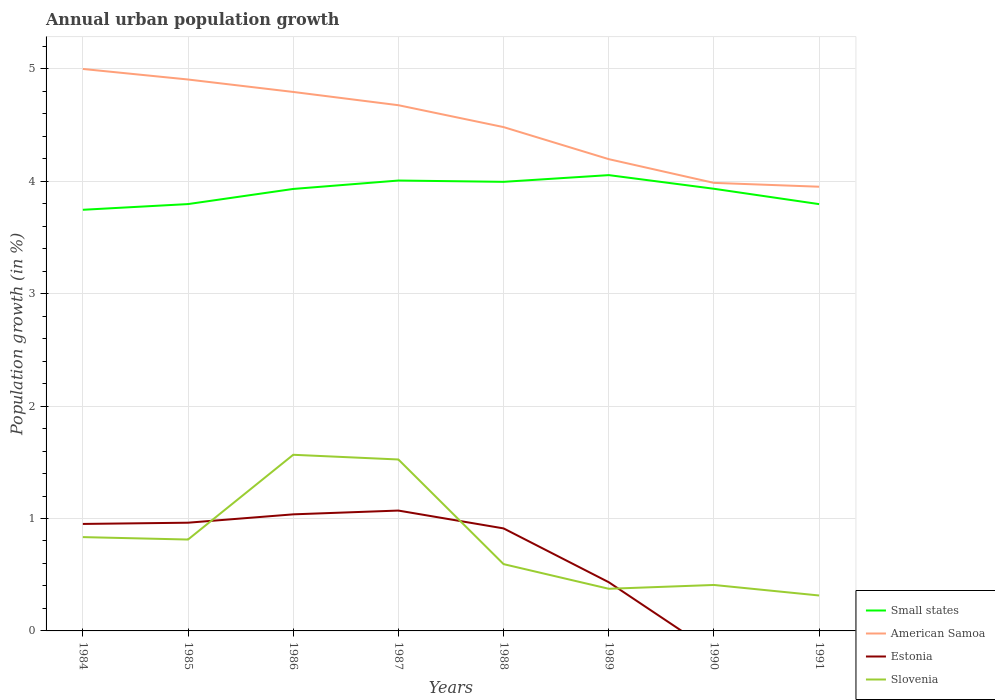How many different coloured lines are there?
Offer a very short reply. 4. Does the line corresponding to Small states intersect with the line corresponding to Slovenia?
Ensure brevity in your answer.  No. Is the number of lines equal to the number of legend labels?
Your answer should be compact. No. Across all years, what is the maximum percentage of urban population growth in Small states?
Your response must be concise. 3.75. What is the total percentage of urban population growth in American Samoa in the graph?
Give a very brief answer. 0.29. What is the difference between the highest and the second highest percentage of urban population growth in Estonia?
Offer a very short reply. 1.07. What is the difference between the highest and the lowest percentage of urban population growth in Small states?
Ensure brevity in your answer.  5. How many years are there in the graph?
Your response must be concise. 8. What is the difference between two consecutive major ticks on the Y-axis?
Your answer should be very brief. 1. How many legend labels are there?
Offer a terse response. 4. How are the legend labels stacked?
Make the answer very short. Vertical. What is the title of the graph?
Ensure brevity in your answer.  Annual urban population growth. Does "Tunisia" appear as one of the legend labels in the graph?
Keep it short and to the point. No. What is the label or title of the X-axis?
Your answer should be very brief. Years. What is the label or title of the Y-axis?
Your response must be concise. Population growth (in %). What is the Population growth (in %) in Small states in 1984?
Offer a very short reply. 3.75. What is the Population growth (in %) in American Samoa in 1984?
Your response must be concise. 5. What is the Population growth (in %) of Estonia in 1984?
Keep it short and to the point. 0.95. What is the Population growth (in %) of Slovenia in 1984?
Provide a short and direct response. 0.83. What is the Population growth (in %) of Small states in 1985?
Your answer should be very brief. 3.8. What is the Population growth (in %) of American Samoa in 1985?
Keep it short and to the point. 4.91. What is the Population growth (in %) of Estonia in 1985?
Your answer should be compact. 0.96. What is the Population growth (in %) in Slovenia in 1985?
Provide a short and direct response. 0.81. What is the Population growth (in %) of Small states in 1986?
Make the answer very short. 3.93. What is the Population growth (in %) of American Samoa in 1986?
Make the answer very short. 4.79. What is the Population growth (in %) of Estonia in 1986?
Offer a very short reply. 1.04. What is the Population growth (in %) of Slovenia in 1986?
Your answer should be very brief. 1.57. What is the Population growth (in %) in Small states in 1987?
Offer a terse response. 4.01. What is the Population growth (in %) in American Samoa in 1987?
Provide a short and direct response. 4.68. What is the Population growth (in %) of Estonia in 1987?
Your answer should be very brief. 1.07. What is the Population growth (in %) of Slovenia in 1987?
Give a very brief answer. 1.53. What is the Population growth (in %) of Small states in 1988?
Your response must be concise. 4. What is the Population growth (in %) of American Samoa in 1988?
Keep it short and to the point. 4.48. What is the Population growth (in %) in Estonia in 1988?
Your answer should be compact. 0.91. What is the Population growth (in %) in Slovenia in 1988?
Your answer should be compact. 0.59. What is the Population growth (in %) of Small states in 1989?
Your answer should be very brief. 4.05. What is the Population growth (in %) of American Samoa in 1989?
Ensure brevity in your answer.  4.2. What is the Population growth (in %) in Estonia in 1989?
Offer a terse response. 0.43. What is the Population growth (in %) of Slovenia in 1989?
Provide a short and direct response. 0.37. What is the Population growth (in %) of Small states in 1990?
Offer a terse response. 3.93. What is the Population growth (in %) in American Samoa in 1990?
Keep it short and to the point. 3.99. What is the Population growth (in %) of Estonia in 1990?
Offer a terse response. 0. What is the Population growth (in %) of Slovenia in 1990?
Give a very brief answer. 0.41. What is the Population growth (in %) in Small states in 1991?
Give a very brief answer. 3.8. What is the Population growth (in %) of American Samoa in 1991?
Offer a very short reply. 3.95. What is the Population growth (in %) in Slovenia in 1991?
Make the answer very short. 0.32. Across all years, what is the maximum Population growth (in %) of Small states?
Provide a succinct answer. 4.05. Across all years, what is the maximum Population growth (in %) of American Samoa?
Offer a terse response. 5. Across all years, what is the maximum Population growth (in %) of Estonia?
Provide a succinct answer. 1.07. Across all years, what is the maximum Population growth (in %) in Slovenia?
Ensure brevity in your answer.  1.57. Across all years, what is the minimum Population growth (in %) in Small states?
Provide a short and direct response. 3.75. Across all years, what is the minimum Population growth (in %) of American Samoa?
Offer a terse response. 3.95. Across all years, what is the minimum Population growth (in %) of Slovenia?
Make the answer very short. 0.32. What is the total Population growth (in %) of Small states in the graph?
Give a very brief answer. 31.26. What is the total Population growth (in %) in American Samoa in the graph?
Keep it short and to the point. 35.99. What is the total Population growth (in %) in Estonia in the graph?
Offer a terse response. 5.37. What is the total Population growth (in %) of Slovenia in the graph?
Provide a succinct answer. 6.43. What is the difference between the Population growth (in %) in Small states in 1984 and that in 1985?
Ensure brevity in your answer.  -0.05. What is the difference between the Population growth (in %) of American Samoa in 1984 and that in 1985?
Ensure brevity in your answer.  0.09. What is the difference between the Population growth (in %) of Estonia in 1984 and that in 1985?
Offer a very short reply. -0.01. What is the difference between the Population growth (in %) of Slovenia in 1984 and that in 1985?
Your response must be concise. 0.02. What is the difference between the Population growth (in %) of Small states in 1984 and that in 1986?
Make the answer very short. -0.19. What is the difference between the Population growth (in %) of American Samoa in 1984 and that in 1986?
Your answer should be very brief. 0.2. What is the difference between the Population growth (in %) in Estonia in 1984 and that in 1986?
Offer a terse response. -0.09. What is the difference between the Population growth (in %) of Slovenia in 1984 and that in 1986?
Give a very brief answer. -0.73. What is the difference between the Population growth (in %) of Small states in 1984 and that in 1987?
Your answer should be very brief. -0.26. What is the difference between the Population growth (in %) of American Samoa in 1984 and that in 1987?
Your answer should be very brief. 0.32. What is the difference between the Population growth (in %) in Estonia in 1984 and that in 1987?
Provide a short and direct response. -0.12. What is the difference between the Population growth (in %) in Slovenia in 1984 and that in 1987?
Give a very brief answer. -0.69. What is the difference between the Population growth (in %) in Small states in 1984 and that in 1988?
Offer a very short reply. -0.25. What is the difference between the Population growth (in %) in American Samoa in 1984 and that in 1988?
Give a very brief answer. 0.52. What is the difference between the Population growth (in %) in Estonia in 1984 and that in 1988?
Your answer should be compact. 0.04. What is the difference between the Population growth (in %) in Slovenia in 1984 and that in 1988?
Your response must be concise. 0.24. What is the difference between the Population growth (in %) of Small states in 1984 and that in 1989?
Keep it short and to the point. -0.31. What is the difference between the Population growth (in %) in American Samoa in 1984 and that in 1989?
Your answer should be compact. 0.8. What is the difference between the Population growth (in %) of Estonia in 1984 and that in 1989?
Your answer should be very brief. 0.52. What is the difference between the Population growth (in %) of Slovenia in 1984 and that in 1989?
Give a very brief answer. 0.46. What is the difference between the Population growth (in %) of Small states in 1984 and that in 1990?
Your response must be concise. -0.19. What is the difference between the Population growth (in %) in American Samoa in 1984 and that in 1990?
Keep it short and to the point. 1.01. What is the difference between the Population growth (in %) in Slovenia in 1984 and that in 1990?
Keep it short and to the point. 0.43. What is the difference between the Population growth (in %) of Small states in 1984 and that in 1991?
Keep it short and to the point. -0.05. What is the difference between the Population growth (in %) in American Samoa in 1984 and that in 1991?
Your response must be concise. 1.05. What is the difference between the Population growth (in %) in Slovenia in 1984 and that in 1991?
Offer a very short reply. 0.52. What is the difference between the Population growth (in %) of Small states in 1985 and that in 1986?
Make the answer very short. -0.13. What is the difference between the Population growth (in %) of American Samoa in 1985 and that in 1986?
Offer a terse response. 0.11. What is the difference between the Population growth (in %) in Estonia in 1985 and that in 1986?
Your answer should be compact. -0.07. What is the difference between the Population growth (in %) in Slovenia in 1985 and that in 1986?
Provide a succinct answer. -0.75. What is the difference between the Population growth (in %) in Small states in 1985 and that in 1987?
Keep it short and to the point. -0.21. What is the difference between the Population growth (in %) of American Samoa in 1985 and that in 1987?
Give a very brief answer. 0.23. What is the difference between the Population growth (in %) of Estonia in 1985 and that in 1987?
Give a very brief answer. -0.11. What is the difference between the Population growth (in %) in Slovenia in 1985 and that in 1987?
Provide a short and direct response. -0.71. What is the difference between the Population growth (in %) in Small states in 1985 and that in 1988?
Your answer should be compact. -0.2. What is the difference between the Population growth (in %) of American Samoa in 1985 and that in 1988?
Keep it short and to the point. 0.42. What is the difference between the Population growth (in %) of Estonia in 1985 and that in 1988?
Make the answer very short. 0.05. What is the difference between the Population growth (in %) in Slovenia in 1985 and that in 1988?
Your answer should be very brief. 0.22. What is the difference between the Population growth (in %) of Small states in 1985 and that in 1989?
Provide a succinct answer. -0.26. What is the difference between the Population growth (in %) in American Samoa in 1985 and that in 1989?
Offer a terse response. 0.71. What is the difference between the Population growth (in %) in Estonia in 1985 and that in 1989?
Make the answer very short. 0.53. What is the difference between the Population growth (in %) of Slovenia in 1985 and that in 1989?
Offer a very short reply. 0.44. What is the difference between the Population growth (in %) of Small states in 1985 and that in 1990?
Offer a very short reply. -0.14. What is the difference between the Population growth (in %) of American Samoa in 1985 and that in 1990?
Provide a succinct answer. 0.92. What is the difference between the Population growth (in %) of Slovenia in 1985 and that in 1990?
Your response must be concise. 0.4. What is the difference between the Population growth (in %) of American Samoa in 1985 and that in 1991?
Offer a very short reply. 0.95. What is the difference between the Population growth (in %) in Slovenia in 1985 and that in 1991?
Your answer should be compact. 0.5. What is the difference between the Population growth (in %) in Small states in 1986 and that in 1987?
Your answer should be compact. -0.07. What is the difference between the Population growth (in %) of American Samoa in 1986 and that in 1987?
Provide a short and direct response. 0.12. What is the difference between the Population growth (in %) of Estonia in 1986 and that in 1987?
Make the answer very short. -0.03. What is the difference between the Population growth (in %) of Slovenia in 1986 and that in 1987?
Provide a short and direct response. 0.04. What is the difference between the Population growth (in %) of Small states in 1986 and that in 1988?
Your response must be concise. -0.06. What is the difference between the Population growth (in %) in American Samoa in 1986 and that in 1988?
Your answer should be compact. 0.31. What is the difference between the Population growth (in %) in Estonia in 1986 and that in 1988?
Your response must be concise. 0.13. What is the difference between the Population growth (in %) of Slovenia in 1986 and that in 1988?
Provide a short and direct response. 0.97. What is the difference between the Population growth (in %) of Small states in 1986 and that in 1989?
Your answer should be very brief. -0.12. What is the difference between the Population growth (in %) in American Samoa in 1986 and that in 1989?
Give a very brief answer. 0.6. What is the difference between the Population growth (in %) of Estonia in 1986 and that in 1989?
Offer a terse response. 0.6. What is the difference between the Population growth (in %) of Slovenia in 1986 and that in 1989?
Provide a succinct answer. 1.19. What is the difference between the Population growth (in %) of Small states in 1986 and that in 1990?
Ensure brevity in your answer.  -0. What is the difference between the Population growth (in %) in American Samoa in 1986 and that in 1990?
Offer a terse response. 0.81. What is the difference between the Population growth (in %) in Slovenia in 1986 and that in 1990?
Keep it short and to the point. 1.16. What is the difference between the Population growth (in %) of Small states in 1986 and that in 1991?
Give a very brief answer. 0.14. What is the difference between the Population growth (in %) in American Samoa in 1986 and that in 1991?
Provide a short and direct response. 0.84. What is the difference between the Population growth (in %) of Slovenia in 1986 and that in 1991?
Give a very brief answer. 1.25. What is the difference between the Population growth (in %) in Small states in 1987 and that in 1988?
Offer a very short reply. 0.01. What is the difference between the Population growth (in %) in American Samoa in 1987 and that in 1988?
Provide a short and direct response. 0.19. What is the difference between the Population growth (in %) in Estonia in 1987 and that in 1988?
Give a very brief answer. 0.16. What is the difference between the Population growth (in %) of Small states in 1987 and that in 1989?
Provide a succinct answer. -0.05. What is the difference between the Population growth (in %) in American Samoa in 1987 and that in 1989?
Give a very brief answer. 0.48. What is the difference between the Population growth (in %) of Estonia in 1987 and that in 1989?
Offer a very short reply. 0.64. What is the difference between the Population growth (in %) in Slovenia in 1987 and that in 1989?
Keep it short and to the point. 1.15. What is the difference between the Population growth (in %) of Small states in 1987 and that in 1990?
Offer a terse response. 0.07. What is the difference between the Population growth (in %) in American Samoa in 1987 and that in 1990?
Offer a terse response. 0.69. What is the difference between the Population growth (in %) of Slovenia in 1987 and that in 1990?
Offer a very short reply. 1.12. What is the difference between the Population growth (in %) of Small states in 1987 and that in 1991?
Give a very brief answer. 0.21. What is the difference between the Population growth (in %) in American Samoa in 1987 and that in 1991?
Give a very brief answer. 0.73. What is the difference between the Population growth (in %) in Slovenia in 1987 and that in 1991?
Offer a terse response. 1.21. What is the difference between the Population growth (in %) of Small states in 1988 and that in 1989?
Provide a succinct answer. -0.06. What is the difference between the Population growth (in %) in American Samoa in 1988 and that in 1989?
Your answer should be very brief. 0.29. What is the difference between the Population growth (in %) of Estonia in 1988 and that in 1989?
Ensure brevity in your answer.  0.48. What is the difference between the Population growth (in %) in Slovenia in 1988 and that in 1989?
Your response must be concise. 0.22. What is the difference between the Population growth (in %) in Small states in 1988 and that in 1990?
Offer a very short reply. 0.06. What is the difference between the Population growth (in %) in American Samoa in 1988 and that in 1990?
Keep it short and to the point. 0.5. What is the difference between the Population growth (in %) in Slovenia in 1988 and that in 1990?
Your answer should be compact. 0.19. What is the difference between the Population growth (in %) in Small states in 1988 and that in 1991?
Your answer should be compact. 0.2. What is the difference between the Population growth (in %) of American Samoa in 1988 and that in 1991?
Provide a short and direct response. 0.53. What is the difference between the Population growth (in %) of Slovenia in 1988 and that in 1991?
Keep it short and to the point. 0.28. What is the difference between the Population growth (in %) of Small states in 1989 and that in 1990?
Your answer should be very brief. 0.12. What is the difference between the Population growth (in %) of American Samoa in 1989 and that in 1990?
Your response must be concise. 0.21. What is the difference between the Population growth (in %) in Slovenia in 1989 and that in 1990?
Give a very brief answer. -0.03. What is the difference between the Population growth (in %) of Small states in 1989 and that in 1991?
Provide a short and direct response. 0.26. What is the difference between the Population growth (in %) in American Samoa in 1989 and that in 1991?
Provide a short and direct response. 0.25. What is the difference between the Population growth (in %) of Slovenia in 1989 and that in 1991?
Make the answer very short. 0.06. What is the difference between the Population growth (in %) of Small states in 1990 and that in 1991?
Provide a succinct answer. 0.14. What is the difference between the Population growth (in %) of American Samoa in 1990 and that in 1991?
Keep it short and to the point. 0.03. What is the difference between the Population growth (in %) of Slovenia in 1990 and that in 1991?
Give a very brief answer. 0.09. What is the difference between the Population growth (in %) in Small states in 1984 and the Population growth (in %) in American Samoa in 1985?
Offer a very short reply. -1.16. What is the difference between the Population growth (in %) in Small states in 1984 and the Population growth (in %) in Estonia in 1985?
Ensure brevity in your answer.  2.78. What is the difference between the Population growth (in %) in Small states in 1984 and the Population growth (in %) in Slovenia in 1985?
Give a very brief answer. 2.93. What is the difference between the Population growth (in %) of American Samoa in 1984 and the Population growth (in %) of Estonia in 1985?
Offer a terse response. 4.04. What is the difference between the Population growth (in %) of American Samoa in 1984 and the Population growth (in %) of Slovenia in 1985?
Offer a terse response. 4.19. What is the difference between the Population growth (in %) in Estonia in 1984 and the Population growth (in %) in Slovenia in 1985?
Keep it short and to the point. 0.14. What is the difference between the Population growth (in %) in Small states in 1984 and the Population growth (in %) in American Samoa in 1986?
Offer a terse response. -1.05. What is the difference between the Population growth (in %) in Small states in 1984 and the Population growth (in %) in Estonia in 1986?
Your answer should be very brief. 2.71. What is the difference between the Population growth (in %) of Small states in 1984 and the Population growth (in %) of Slovenia in 1986?
Offer a terse response. 2.18. What is the difference between the Population growth (in %) of American Samoa in 1984 and the Population growth (in %) of Estonia in 1986?
Make the answer very short. 3.96. What is the difference between the Population growth (in %) of American Samoa in 1984 and the Population growth (in %) of Slovenia in 1986?
Provide a short and direct response. 3.43. What is the difference between the Population growth (in %) in Estonia in 1984 and the Population growth (in %) in Slovenia in 1986?
Offer a terse response. -0.62. What is the difference between the Population growth (in %) in Small states in 1984 and the Population growth (in %) in American Samoa in 1987?
Offer a very short reply. -0.93. What is the difference between the Population growth (in %) in Small states in 1984 and the Population growth (in %) in Estonia in 1987?
Keep it short and to the point. 2.68. What is the difference between the Population growth (in %) in Small states in 1984 and the Population growth (in %) in Slovenia in 1987?
Give a very brief answer. 2.22. What is the difference between the Population growth (in %) in American Samoa in 1984 and the Population growth (in %) in Estonia in 1987?
Provide a short and direct response. 3.93. What is the difference between the Population growth (in %) of American Samoa in 1984 and the Population growth (in %) of Slovenia in 1987?
Give a very brief answer. 3.47. What is the difference between the Population growth (in %) in Estonia in 1984 and the Population growth (in %) in Slovenia in 1987?
Provide a short and direct response. -0.57. What is the difference between the Population growth (in %) of Small states in 1984 and the Population growth (in %) of American Samoa in 1988?
Provide a succinct answer. -0.74. What is the difference between the Population growth (in %) of Small states in 1984 and the Population growth (in %) of Estonia in 1988?
Give a very brief answer. 2.83. What is the difference between the Population growth (in %) of Small states in 1984 and the Population growth (in %) of Slovenia in 1988?
Offer a very short reply. 3.15. What is the difference between the Population growth (in %) of American Samoa in 1984 and the Population growth (in %) of Estonia in 1988?
Provide a succinct answer. 4.09. What is the difference between the Population growth (in %) of American Samoa in 1984 and the Population growth (in %) of Slovenia in 1988?
Offer a very short reply. 4.41. What is the difference between the Population growth (in %) of Estonia in 1984 and the Population growth (in %) of Slovenia in 1988?
Offer a terse response. 0.36. What is the difference between the Population growth (in %) of Small states in 1984 and the Population growth (in %) of American Samoa in 1989?
Provide a succinct answer. -0.45. What is the difference between the Population growth (in %) of Small states in 1984 and the Population growth (in %) of Estonia in 1989?
Give a very brief answer. 3.31. What is the difference between the Population growth (in %) of Small states in 1984 and the Population growth (in %) of Slovenia in 1989?
Your answer should be compact. 3.37. What is the difference between the Population growth (in %) in American Samoa in 1984 and the Population growth (in %) in Estonia in 1989?
Your response must be concise. 4.57. What is the difference between the Population growth (in %) of American Samoa in 1984 and the Population growth (in %) of Slovenia in 1989?
Offer a terse response. 4.62. What is the difference between the Population growth (in %) of Estonia in 1984 and the Population growth (in %) of Slovenia in 1989?
Provide a short and direct response. 0.58. What is the difference between the Population growth (in %) of Small states in 1984 and the Population growth (in %) of American Samoa in 1990?
Keep it short and to the point. -0.24. What is the difference between the Population growth (in %) of Small states in 1984 and the Population growth (in %) of Slovenia in 1990?
Offer a very short reply. 3.34. What is the difference between the Population growth (in %) of American Samoa in 1984 and the Population growth (in %) of Slovenia in 1990?
Offer a very short reply. 4.59. What is the difference between the Population growth (in %) in Estonia in 1984 and the Population growth (in %) in Slovenia in 1990?
Your answer should be compact. 0.54. What is the difference between the Population growth (in %) in Small states in 1984 and the Population growth (in %) in American Samoa in 1991?
Provide a succinct answer. -0.21. What is the difference between the Population growth (in %) in Small states in 1984 and the Population growth (in %) in Slovenia in 1991?
Your answer should be compact. 3.43. What is the difference between the Population growth (in %) of American Samoa in 1984 and the Population growth (in %) of Slovenia in 1991?
Your answer should be compact. 4.68. What is the difference between the Population growth (in %) of Estonia in 1984 and the Population growth (in %) of Slovenia in 1991?
Keep it short and to the point. 0.64. What is the difference between the Population growth (in %) in Small states in 1985 and the Population growth (in %) in American Samoa in 1986?
Your response must be concise. -1. What is the difference between the Population growth (in %) of Small states in 1985 and the Population growth (in %) of Estonia in 1986?
Make the answer very short. 2.76. What is the difference between the Population growth (in %) of Small states in 1985 and the Population growth (in %) of Slovenia in 1986?
Offer a very short reply. 2.23. What is the difference between the Population growth (in %) in American Samoa in 1985 and the Population growth (in %) in Estonia in 1986?
Provide a short and direct response. 3.87. What is the difference between the Population growth (in %) of American Samoa in 1985 and the Population growth (in %) of Slovenia in 1986?
Offer a terse response. 3.34. What is the difference between the Population growth (in %) in Estonia in 1985 and the Population growth (in %) in Slovenia in 1986?
Keep it short and to the point. -0.6. What is the difference between the Population growth (in %) of Small states in 1985 and the Population growth (in %) of American Samoa in 1987?
Provide a short and direct response. -0.88. What is the difference between the Population growth (in %) in Small states in 1985 and the Population growth (in %) in Estonia in 1987?
Offer a terse response. 2.73. What is the difference between the Population growth (in %) of Small states in 1985 and the Population growth (in %) of Slovenia in 1987?
Provide a short and direct response. 2.27. What is the difference between the Population growth (in %) in American Samoa in 1985 and the Population growth (in %) in Estonia in 1987?
Your answer should be very brief. 3.83. What is the difference between the Population growth (in %) in American Samoa in 1985 and the Population growth (in %) in Slovenia in 1987?
Offer a terse response. 3.38. What is the difference between the Population growth (in %) of Estonia in 1985 and the Population growth (in %) of Slovenia in 1987?
Provide a short and direct response. -0.56. What is the difference between the Population growth (in %) of Small states in 1985 and the Population growth (in %) of American Samoa in 1988?
Make the answer very short. -0.68. What is the difference between the Population growth (in %) in Small states in 1985 and the Population growth (in %) in Estonia in 1988?
Keep it short and to the point. 2.89. What is the difference between the Population growth (in %) in Small states in 1985 and the Population growth (in %) in Slovenia in 1988?
Keep it short and to the point. 3.2. What is the difference between the Population growth (in %) of American Samoa in 1985 and the Population growth (in %) of Estonia in 1988?
Keep it short and to the point. 3.99. What is the difference between the Population growth (in %) in American Samoa in 1985 and the Population growth (in %) in Slovenia in 1988?
Ensure brevity in your answer.  4.31. What is the difference between the Population growth (in %) of Estonia in 1985 and the Population growth (in %) of Slovenia in 1988?
Your response must be concise. 0.37. What is the difference between the Population growth (in %) of Small states in 1985 and the Population growth (in %) of American Samoa in 1989?
Offer a very short reply. -0.4. What is the difference between the Population growth (in %) in Small states in 1985 and the Population growth (in %) in Estonia in 1989?
Provide a short and direct response. 3.36. What is the difference between the Population growth (in %) of Small states in 1985 and the Population growth (in %) of Slovenia in 1989?
Your answer should be compact. 3.42. What is the difference between the Population growth (in %) of American Samoa in 1985 and the Population growth (in %) of Estonia in 1989?
Give a very brief answer. 4.47. What is the difference between the Population growth (in %) of American Samoa in 1985 and the Population growth (in %) of Slovenia in 1989?
Provide a succinct answer. 4.53. What is the difference between the Population growth (in %) in Estonia in 1985 and the Population growth (in %) in Slovenia in 1989?
Make the answer very short. 0.59. What is the difference between the Population growth (in %) in Small states in 1985 and the Population growth (in %) in American Samoa in 1990?
Give a very brief answer. -0.19. What is the difference between the Population growth (in %) of Small states in 1985 and the Population growth (in %) of Slovenia in 1990?
Offer a very short reply. 3.39. What is the difference between the Population growth (in %) of American Samoa in 1985 and the Population growth (in %) of Slovenia in 1990?
Offer a very short reply. 4.5. What is the difference between the Population growth (in %) in Estonia in 1985 and the Population growth (in %) in Slovenia in 1990?
Provide a short and direct response. 0.55. What is the difference between the Population growth (in %) in Small states in 1985 and the Population growth (in %) in American Samoa in 1991?
Provide a succinct answer. -0.15. What is the difference between the Population growth (in %) in Small states in 1985 and the Population growth (in %) in Slovenia in 1991?
Keep it short and to the point. 3.48. What is the difference between the Population growth (in %) of American Samoa in 1985 and the Population growth (in %) of Slovenia in 1991?
Make the answer very short. 4.59. What is the difference between the Population growth (in %) in Estonia in 1985 and the Population growth (in %) in Slovenia in 1991?
Keep it short and to the point. 0.65. What is the difference between the Population growth (in %) in Small states in 1986 and the Population growth (in %) in American Samoa in 1987?
Provide a succinct answer. -0.74. What is the difference between the Population growth (in %) in Small states in 1986 and the Population growth (in %) in Estonia in 1987?
Give a very brief answer. 2.86. What is the difference between the Population growth (in %) in Small states in 1986 and the Population growth (in %) in Slovenia in 1987?
Provide a succinct answer. 2.41. What is the difference between the Population growth (in %) of American Samoa in 1986 and the Population growth (in %) of Estonia in 1987?
Make the answer very short. 3.72. What is the difference between the Population growth (in %) in American Samoa in 1986 and the Population growth (in %) in Slovenia in 1987?
Provide a short and direct response. 3.27. What is the difference between the Population growth (in %) of Estonia in 1986 and the Population growth (in %) of Slovenia in 1987?
Provide a succinct answer. -0.49. What is the difference between the Population growth (in %) of Small states in 1986 and the Population growth (in %) of American Samoa in 1988?
Your answer should be compact. -0.55. What is the difference between the Population growth (in %) in Small states in 1986 and the Population growth (in %) in Estonia in 1988?
Provide a short and direct response. 3.02. What is the difference between the Population growth (in %) of Small states in 1986 and the Population growth (in %) of Slovenia in 1988?
Offer a terse response. 3.34. What is the difference between the Population growth (in %) in American Samoa in 1986 and the Population growth (in %) in Estonia in 1988?
Provide a succinct answer. 3.88. What is the difference between the Population growth (in %) in American Samoa in 1986 and the Population growth (in %) in Slovenia in 1988?
Your response must be concise. 4.2. What is the difference between the Population growth (in %) of Estonia in 1986 and the Population growth (in %) of Slovenia in 1988?
Your answer should be very brief. 0.44. What is the difference between the Population growth (in %) in Small states in 1986 and the Population growth (in %) in American Samoa in 1989?
Give a very brief answer. -0.27. What is the difference between the Population growth (in %) in Small states in 1986 and the Population growth (in %) in Estonia in 1989?
Offer a very short reply. 3.5. What is the difference between the Population growth (in %) of Small states in 1986 and the Population growth (in %) of Slovenia in 1989?
Provide a short and direct response. 3.56. What is the difference between the Population growth (in %) in American Samoa in 1986 and the Population growth (in %) in Estonia in 1989?
Your response must be concise. 4.36. What is the difference between the Population growth (in %) in American Samoa in 1986 and the Population growth (in %) in Slovenia in 1989?
Make the answer very short. 4.42. What is the difference between the Population growth (in %) of Estonia in 1986 and the Population growth (in %) of Slovenia in 1989?
Keep it short and to the point. 0.66. What is the difference between the Population growth (in %) in Small states in 1986 and the Population growth (in %) in American Samoa in 1990?
Your answer should be compact. -0.05. What is the difference between the Population growth (in %) of Small states in 1986 and the Population growth (in %) of Slovenia in 1990?
Offer a terse response. 3.52. What is the difference between the Population growth (in %) in American Samoa in 1986 and the Population growth (in %) in Slovenia in 1990?
Ensure brevity in your answer.  4.39. What is the difference between the Population growth (in %) in Estonia in 1986 and the Population growth (in %) in Slovenia in 1990?
Ensure brevity in your answer.  0.63. What is the difference between the Population growth (in %) in Small states in 1986 and the Population growth (in %) in American Samoa in 1991?
Offer a terse response. -0.02. What is the difference between the Population growth (in %) in Small states in 1986 and the Population growth (in %) in Slovenia in 1991?
Your answer should be very brief. 3.62. What is the difference between the Population growth (in %) of American Samoa in 1986 and the Population growth (in %) of Slovenia in 1991?
Give a very brief answer. 4.48. What is the difference between the Population growth (in %) in Estonia in 1986 and the Population growth (in %) in Slovenia in 1991?
Make the answer very short. 0.72. What is the difference between the Population growth (in %) of Small states in 1987 and the Population growth (in %) of American Samoa in 1988?
Your answer should be compact. -0.48. What is the difference between the Population growth (in %) in Small states in 1987 and the Population growth (in %) in Estonia in 1988?
Provide a succinct answer. 3.09. What is the difference between the Population growth (in %) in Small states in 1987 and the Population growth (in %) in Slovenia in 1988?
Keep it short and to the point. 3.41. What is the difference between the Population growth (in %) of American Samoa in 1987 and the Population growth (in %) of Estonia in 1988?
Your response must be concise. 3.76. What is the difference between the Population growth (in %) of American Samoa in 1987 and the Population growth (in %) of Slovenia in 1988?
Give a very brief answer. 4.08. What is the difference between the Population growth (in %) in Estonia in 1987 and the Population growth (in %) in Slovenia in 1988?
Your answer should be very brief. 0.48. What is the difference between the Population growth (in %) of Small states in 1987 and the Population growth (in %) of American Samoa in 1989?
Give a very brief answer. -0.19. What is the difference between the Population growth (in %) of Small states in 1987 and the Population growth (in %) of Estonia in 1989?
Give a very brief answer. 3.57. What is the difference between the Population growth (in %) in Small states in 1987 and the Population growth (in %) in Slovenia in 1989?
Your answer should be very brief. 3.63. What is the difference between the Population growth (in %) in American Samoa in 1987 and the Population growth (in %) in Estonia in 1989?
Give a very brief answer. 4.24. What is the difference between the Population growth (in %) of American Samoa in 1987 and the Population growth (in %) of Slovenia in 1989?
Give a very brief answer. 4.3. What is the difference between the Population growth (in %) of Estonia in 1987 and the Population growth (in %) of Slovenia in 1989?
Your answer should be compact. 0.7. What is the difference between the Population growth (in %) of Small states in 1987 and the Population growth (in %) of American Samoa in 1990?
Your response must be concise. 0.02. What is the difference between the Population growth (in %) of Small states in 1987 and the Population growth (in %) of Slovenia in 1990?
Provide a short and direct response. 3.6. What is the difference between the Population growth (in %) of American Samoa in 1987 and the Population growth (in %) of Slovenia in 1990?
Provide a succinct answer. 4.27. What is the difference between the Population growth (in %) of Estonia in 1987 and the Population growth (in %) of Slovenia in 1990?
Your response must be concise. 0.66. What is the difference between the Population growth (in %) in Small states in 1987 and the Population growth (in %) in American Samoa in 1991?
Give a very brief answer. 0.06. What is the difference between the Population growth (in %) in Small states in 1987 and the Population growth (in %) in Slovenia in 1991?
Keep it short and to the point. 3.69. What is the difference between the Population growth (in %) of American Samoa in 1987 and the Population growth (in %) of Slovenia in 1991?
Keep it short and to the point. 4.36. What is the difference between the Population growth (in %) of Estonia in 1987 and the Population growth (in %) of Slovenia in 1991?
Your answer should be very brief. 0.76. What is the difference between the Population growth (in %) in Small states in 1988 and the Population growth (in %) in American Samoa in 1989?
Your response must be concise. -0.2. What is the difference between the Population growth (in %) in Small states in 1988 and the Population growth (in %) in Estonia in 1989?
Your answer should be very brief. 3.56. What is the difference between the Population growth (in %) in Small states in 1988 and the Population growth (in %) in Slovenia in 1989?
Your answer should be compact. 3.62. What is the difference between the Population growth (in %) in American Samoa in 1988 and the Population growth (in %) in Estonia in 1989?
Provide a short and direct response. 4.05. What is the difference between the Population growth (in %) in American Samoa in 1988 and the Population growth (in %) in Slovenia in 1989?
Offer a terse response. 4.11. What is the difference between the Population growth (in %) of Estonia in 1988 and the Population growth (in %) of Slovenia in 1989?
Provide a short and direct response. 0.54. What is the difference between the Population growth (in %) of Small states in 1988 and the Population growth (in %) of American Samoa in 1990?
Offer a very short reply. 0.01. What is the difference between the Population growth (in %) in Small states in 1988 and the Population growth (in %) in Slovenia in 1990?
Provide a succinct answer. 3.59. What is the difference between the Population growth (in %) of American Samoa in 1988 and the Population growth (in %) of Slovenia in 1990?
Your answer should be very brief. 4.07. What is the difference between the Population growth (in %) of Estonia in 1988 and the Population growth (in %) of Slovenia in 1990?
Provide a succinct answer. 0.5. What is the difference between the Population growth (in %) in Small states in 1988 and the Population growth (in %) in American Samoa in 1991?
Ensure brevity in your answer.  0.04. What is the difference between the Population growth (in %) of Small states in 1988 and the Population growth (in %) of Slovenia in 1991?
Your answer should be compact. 3.68. What is the difference between the Population growth (in %) of American Samoa in 1988 and the Population growth (in %) of Slovenia in 1991?
Your response must be concise. 4.17. What is the difference between the Population growth (in %) in Estonia in 1988 and the Population growth (in %) in Slovenia in 1991?
Your answer should be very brief. 0.6. What is the difference between the Population growth (in %) in Small states in 1989 and the Population growth (in %) in American Samoa in 1990?
Keep it short and to the point. 0.07. What is the difference between the Population growth (in %) in Small states in 1989 and the Population growth (in %) in Slovenia in 1990?
Your response must be concise. 3.65. What is the difference between the Population growth (in %) of American Samoa in 1989 and the Population growth (in %) of Slovenia in 1990?
Keep it short and to the point. 3.79. What is the difference between the Population growth (in %) of Estonia in 1989 and the Population growth (in %) of Slovenia in 1990?
Your response must be concise. 0.02. What is the difference between the Population growth (in %) of Small states in 1989 and the Population growth (in %) of American Samoa in 1991?
Make the answer very short. 0.1. What is the difference between the Population growth (in %) in Small states in 1989 and the Population growth (in %) in Slovenia in 1991?
Keep it short and to the point. 3.74. What is the difference between the Population growth (in %) of American Samoa in 1989 and the Population growth (in %) of Slovenia in 1991?
Offer a terse response. 3.88. What is the difference between the Population growth (in %) of Estonia in 1989 and the Population growth (in %) of Slovenia in 1991?
Offer a very short reply. 0.12. What is the difference between the Population growth (in %) of Small states in 1990 and the Population growth (in %) of American Samoa in 1991?
Your answer should be very brief. -0.02. What is the difference between the Population growth (in %) in Small states in 1990 and the Population growth (in %) in Slovenia in 1991?
Give a very brief answer. 3.62. What is the difference between the Population growth (in %) of American Samoa in 1990 and the Population growth (in %) of Slovenia in 1991?
Give a very brief answer. 3.67. What is the average Population growth (in %) in Small states per year?
Offer a terse response. 3.91. What is the average Population growth (in %) in American Samoa per year?
Your answer should be very brief. 4.5. What is the average Population growth (in %) of Estonia per year?
Provide a short and direct response. 0.67. What is the average Population growth (in %) in Slovenia per year?
Your answer should be very brief. 0.8. In the year 1984, what is the difference between the Population growth (in %) in Small states and Population growth (in %) in American Samoa?
Your answer should be compact. -1.25. In the year 1984, what is the difference between the Population growth (in %) of Small states and Population growth (in %) of Estonia?
Ensure brevity in your answer.  2.79. In the year 1984, what is the difference between the Population growth (in %) of Small states and Population growth (in %) of Slovenia?
Provide a short and direct response. 2.91. In the year 1984, what is the difference between the Population growth (in %) in American Samoa and Population growth (in %) in Estonia?
Your response must be concise. 4.05. In the year 1984, what is the difference between the Population growth (in %) in American Samoa and Population growth (in %) in Slovenia?
Make the answer very short. 4.16. In the year 1984, what is the difference between the Population growth (in %) of Estonia and Population growth (in %) of Slovenia?
Keep it short and to the point. 0.12. In the year 1985, what is the difference between the Population growth (in %) of Small states and Population growth (in %) of American Samoa?
Your answer should be very brief. -1.11. In the year 1985, what is the difference between the Population growth (in %) in Small states and Population growth (in %) in Estonia?
Your answer should be very brief. 2.83. In the year 1985, what is the difference between the Population growth (in %) in Small states and Population growth (in %) in Slovenia?
Give a very brief answer. 2.98. In the year 1985, what is the difference between the Population growth (in %) of American Samoa and Population growth (in %) of Estonia?
Offer a very short reply. 3.94. In the year 1985, what is the difference between the Population growth (in %) of American Samoa and Population growth (in %) of Slovenia?
Give a very brief answer. 4.09. In the year 1985, what is the difference between the Population growth (in %) of Estonia and Population growth (in %) of Slovenia?
Your response must be concise. 0.15. In the year 1986, what is the difference between the Population growth (in %) of Small states and Population growth (in %) of American Samoa?
Your response must be concise. -0.86. In the year 1986, what is the difference between the Population growth (in %) of Small states and Population growth (in %) of Estonia?
Provide a succinct answer. 2.89. In the year 1986, what is the difference between the Population growth (in %) of Small states and Population growth (in %) of Slovenia?
Ensure brevity in your answer.  2.36. In the year 1986, what is the difference between the Population growth (in %) in American Samoa and Population growth (in %) in Estonia?
Offer a terse response. 3.76. In the year 1986, what is the difference between the Population growth (in %) of American Samoa and Population growth (in %) of Slovenia?
Provide a succinct answer. 3.23. In the year 1986, what is the difference between the Population growth (in %) in Estonia and Population growth (in %) in Slovenia?
Offer a very short reply. -0.53. In the year 1987, what is the difference between the Population growth (in %) in Small states and Population growth (in %) in American Samoa?
Make the answer very short. -0.67. In the year 1987, what is the difference between the Population growth (in %) in Small states and Population growth (in %) in Estonia?
Your response must be concise. 2.94. In the year 1987, what is the difference between the Population growth (in %) in Small states and Population growth (in %) in Slovenia?
Your answer should be very brief. 2.48. In the year 1987, what is the difference between the Population growth (in %) in American Samoa and Population growth (in %) in Estonia?
Provide a succinct answer. 3.61. In the year 1987, what is the difference between the Population growth (in %) in American Samoa and Population growth (in %) in Slovenia?
Your answer should be compact. 3.15. In the year 1987, what is the difference between the Population growth (in %) in Estonia and Population growth (in %) in Slovenia?
Give a very brief answer. -0.45. In the year 1988, what is the difference between the Population growth (in %) in Small states and Population growth (in %) in American Samoa?
Make the answer very short. -0.49. In the year 1988, what is the difference between the Population growth (in %) of Small states and Population growth (in %) of Estonia?
Offer a very short reply. 3.08. In the year 1988, what is the difference between the Population growth (in %) of Small states and Population growth (in %) of Slovenia?
Your answer should be compact. 3.4. In the year 1988, what is the difference between the Population growth (in %) in American Samoa and Population growth (in %) in Estonia?
Keep it short and to the point. 3.57. In the year 1988, what is the difference between the Population growth (in %) of American Samoa and Population growth (in %) of Slovenia?
Keep it short and to the point. 3.89. In the year 1988, what is the difference between the Population growth (in %) of Estonia and Population growth (in %) of Slovenia?
Keep it short and to the point. 0.32. In the year 1989, what is the difference between the Population growth (in %) in Small states and Population growth (in %) in American Samoa?
Ensure brevity in your answer.  -0.14. In the year 1989, what is the difference between the Population growth (in %) of Small states and Population growth (in %) of Estonia?
Ensure brevity in your answer.  3.62. In the year 1989, what is the difference between the Population growth (in %) of Small states and Population growth (in %) of Slovenia?
Your answer should be compact. 3.68. In the year 1989, what is the difference between the Population growth (in %) of American Samoa and Population growth (in %) of Estonia?
Offer a very short reply. 3.76. In the year 1989, what is the difference between the Population growth (in %) in American Samoa and Population growth (in %) in Slovenia?
Offer a very short reply. 3.82. In the year 1989, what is the difference between the Population growth (in %) in Estonia and Population growth (in %) in Slovenia?
Keep it short and to the point. 0.06. In the year 1990, what is the difference between the Population growth (in %) in Small states and Population growth (in %) in American Samoa?
Keep it short and to the point. -0.05. In the year 1990, what is the difference between the Population growth (in %) in Small states and Population growth (in %) in Slovenia?
Keep it short and to the point. 3.52. In the year 1990, what is the difference between the Population growth (in %) in American Samoa and Population growth (in %) in Slovenia?
Your answer should be compact. 3.58. In the year 1991, what is the difference between the Population growth (in %) of Small states and Population growth (in %) of American Samoa?
Your response must be concise. -0.15. In the year 1991, what is the difference between the Population growth (in %) of Small states and Population growth (in %) of Slovenia?
Offer a terse response. 3.48. In the year 1991, what is the difference between the Population growth (in %) in American Samoa and Population growth (in %) in Slovenia?
Your response must be concise. 3.64. What is the ratio of the Population growth (in %) in Small states in 1984 to that in 1985?
Offer a terse response. 0.99. What is the ratio of the Population growth (in %) of American Samoa in 1984 to that in 1985?
Provide a short and direct response. 1.02. What is the ratio of the Population growth (in %) of Estonia in 1984 to that in 1985?
Ensure brevity in your answer.  0.99. What is the ratio of the Population growth (in %) in Slovenia in 1984 to that in 1985?
Keep it short and to the point. 1.03. What is the ratio of the Population growth (in %) of Small states in 1984 to that in 1986?
Offer a very short reply. 0.95. What is the ratio of the Population growth (in %) in American Samoa in 1984 to that in 1986?
Your answer should be compact. 1.04. What is the ratio of the Population growth (in %) of Estonia in 1984 to that in 1986?
Ensure brevity in your answer.  0.92. What is the ratio of the Population growth (in %) in Slovenia in 1984 to that in 1986?
Ensure brevity in your answer.  0.53. What is the ratio of the Population growth (in %) in Small states in 1984 to that in 1987?
Offer a very short reply. 0.94. What is the ratio of the Population growth (in %) in American Samoa in 1984 to that in 1987?
Your response must be concise. 1.07. What is the ratio of the Population growth (in %) of Slovenia in 1984 to that in 1987?
Offer a very short reply. 0.55. What is the ratio of the Population growth (in %) in Small states in 1984 to that in 1988?
Give a very brief answer. 0.94. What is the ratio of the Population growth (in %) in American Samoa in 1984 to that in 1988?
Offer a very short reply. 1.12. What is the ratio of the Population growth (in %) of Estonia in 1984 to that in 1988?
Give a very brief answer. 1.04. What is the ratio of the Population growth (in %) in Slovenia in 1984 to that in 1988?
Provide a short and direct response. 1.4. What is the ratio of the Population growth (in %) in Small states in 1984 to that in 1989?
Offer a very short reply. 0.92. What is the ratio of the Population growth (in %) in American Samoa in 1984 to that in 1989?
Offer a terse response. 1.19. What is the ratio of the Population growth (in %) in Estonia in 1984 to that in 1989?
Provide a succinct answer. 2.2. What is the ratio of the Population growth (in %) of Slovenia in 1984 to that in 1989?
Your answer should be compact. 2.23. What is the ratio of the Population growth (in %) in Small states in 1984 to that in 1990?
Provide a short and direct response. 0.95. What is the ratio of the Population growth (in %) of American Samoa in 1984 to that in 1990?
Your answer should be very brief. 1.25. What is the ratio of the Population growth (in %) in Slovenia in 1984 to that in 1990?
Ensure brevity in your answer.  2.04. What is the ratio of the Population growth (in %) of American Samoa in 1984 to that in 1991?
Keep it short and to the point. 1.27. What is the ratio of the Population growth (in %) in Slovenia in 1984 to that in 1991?
Your answer should be compact. 2.65. What is the ratio of the Population growth (in %) of Small states in 1985 to that in 1986?
Provide a succinct answer. 0.97. What is the ratio of the Population growth (in %) of American Samoa in 1985 to that in 1986?
Your answer should be very brief. 1.02. What is the ratio of the Population growth (in %) in Estonia in 1985 to that in 1986?
Offer a very short reply. 0.93. What is the ratio of the Population growth (in %) in Slovenia in 1985 to that in 1986?
Keep it short and to the point. 0.52. What is the ratio of the Population growth (in %) in Small states in 1985 to that in 1987?
Give a very brief answer. 0.95. What is the ratio of the Population growth (in %) in American Samoa in 1985 to that in 1987?
Your answer should be very brief. 1.05. What is the ratio of the Population growth (in %) of Estonia in 1985 to that in 1987?
Offer a very short reply. 0.9. What is the ratio of the Population growth (in %) of Slovenia in 1985 to that in 1987?
Offer a terse response. 0.53. What is the ratio of the Population growth (in %) in Small states in 1985 to that in 1988?
Provide a succinct answer. 0.95. What is the ratio of the Population growth (in %) in American Samoa in 1985 to that in 1988?
Offer a terse response. 1.09. What is the ratio of the Population growth (in %) of Estonia in 1985 to that in 1988?
Your answer should be compact. 1.06. What is the ratio of the Population growth (in %) in Slovenia in 1985 to that in 1988?
Keep it short and to the point. 1.37. What is the ratio of the Population growth (in %) in Small states in 1985 to that in 1989?
Provide a short and direct response. 0.94. What is the ratio of the Population growth (in %) of American Samoa in 1985 to that in 1989?
Your response must be concise. 1.17. What is the ratio of the Population growth (in %) in Estonia in 1985 to that in 1989?
Your answer should be very brief. 2.22. What is the ratio of the Population growth (in %) of Slovenia in 1985 to that in 1989?
Offer a terse response. 2.17. What is the ratio of the Population growth (in %) in Small states in 1985 to that in 1990?
Provide a short and direct response. 0.97. What is the ratio of the Population growth (in %) of American Samoa in 1985 to that in 1990?
Your answer should be very brief. 1.23. What is the ratio of the Population growth (in %) of Slovenia in 1985 to that in 1990?
Provide a short and direct response. 1.99. What is the ratio of the Population growth (in %) of American Samoa in 1985 to that in 1991?
Your answer should be compact. 1.24. What is the ratio of the Population growth (in %) in Slovenia in 1985 to that in 1991?
Offer a very short reply. 2.58. What is the ratio of the Population growth (in %) of Small states in 1986 to that in 1987?
Your answer should be compact. 0.98. What is the ratio of the Population growth (in %) in American Samoa in 1986 to that in 1987?
Make the answer very short. 1.03. What is the ratio of the Population growth (in %) in Estonia in 1986 to that in 1987?
Offer a very short reply. 0.97. What is the ratio of the Population growth (in %) in Slovenia in 1986 to that in 1987?
Offer a very short reply. 1.03. What is the ratio of the Population growth (in %) of Small states in 1986 to that in 1988?
Make the answer very short. 0.98. What is the ratio of the Population growth (in %) of American Samoa in 1986 to that in 1988?
Keep it short and to the point. 1.07. What is the ratio of the Population growth (in %) in Estonia in 1986 to that in 1988?
Make the answer very short. 1.14. What is the ratio of the Population growth (in %) of Slovenia in 1986 to that in 1988?
Give a very brief answer. 2.64. What is the ratio of the Population growth (in %) in Small states in 1986 to that in 1989?
Offer a very short reply. 0.97. What is the ratio of the Population growth (in %) in American Samoa in 1986 to that in 1989?
Make the answer very short. 1.14. What is the ratio of the Population growth (in %) in Estonia in 1986 to that in 1989?
Your response must be concise. 2.39. What is the ratio of the Population growth (in %) of Slovenia in 1986 to that in 1989?
Give a very brief answer. 4.18. What is the ratio of the Population growth (in %) of American Samoa in 1986 to that in 1990?
Offer a very short reply. 1.2. What is the ratio of the Population growth (in %) in Slovenia in 1986 to that in 1990?
Offer a very short reply. 3.83. What is the ratio of the Population growth (in %) in Small states in 1986 to that in 1991?
Provide a succinct answer. 1.04. What is the ratio of the Population growth (in %) in American Samoa in 1986 to that in 1991?
Offer a very short reply. 1.21. What is the ratio of the Population growth (in %) of Slovenia in 1986 to that in 1991?
Provide a short and direct response. 4.97. What is the ratio of the Population growth (in %) of Small states in 1987 to that in 1988?
Your response must be concise. 1. What is the ratio of the Population growth (in %) in American Samoa in 1987 to that in 1988?
Ensure brevity in your answer.  1.04. What is the ratio of the Population growth (in %) in Estonia in 1987 to that in 1988?
Provide a succinct answer. 1.17. What is the ratio of the Population growth (in %) of Slovenia in 1987 to that in 1988?
Keep it short and to the point. 2.57. What is the ratio of the Population growth (in %) in Small states in 1987 to that in 1989?
Provide a succinct answer. 0.99. What is the ratio of the Population growth (in %) in American Samoa in 1987 to that in 1989?
Offer a terse response. 1.11. What is the ratio of the Population growth (in %) in Estonia in 1987 to that in 1989?
Make the answer very short. 2.47. What is the ratio of the Population growth (in %) in Slovenia in 1987 to that in 1989?
Keep it short and to the point. 4.07. What is the ratio of the Population growth (in %) in Small states in 1987 to that in 1990?
Your response must be concise. 1.02. What is the ratio of the Population growth (in %) in American Samoa in 1987 to that in 1990?
Provide a succinct answer. 1.17. What is the ratio of the Population growth (in %) of Slovenia in 1987 to that in 1990?
Provide a short and direct response. 3.73. What is the ratio of the Population growth (in %) in Small states in 1987 to that in 1991?
Your response must be concise. 1.06. What is the ratio of the Population growth (in %) of American Samoa in 1987 to that in 1991?
Provide a short and direct response. 1.18. What is the ratio of the Population growth (in %) in Slovenia in 1987 to that in 1991?
Offer a terse response. 4.84. What is the ratio of the Population growth (in %) in Small states in 1988 to that in 1989?
Offer a very short reply. 0.99. What is the ratio of the Population growth (in %) in American Samoa in 1988 to that in 1989?
Offer a terse response. 1.07. What is the ratio of the Population growth (in %) in Estonia in 1988 to that in 1989?
Ensure brevity in your answer.  2.11. What is the ratio of the Population growth (in %) in Slovenia in 1988 to that in 1989?
Your answer should be compact. 1.58. What is the ratio of the Population growth (in %) of Small states in 1988 to that in 1990?
Keep it short and to the point. 1.02. What is the ratio of the Population growth (in %) in American Samoa in 1988 to that in 1990?
Your response must be concise. 1.12. What is the ratio of the Population growth (in %) in Slovenia in 1988 to that in 1990?
Offer a terse response. 1.45. What is the ratio of the Population growth (in %) in Small states in 1988 to that in 1991?
Ensure brevity in your answer.  1.05. What is the ratio of the Population growth (in %) in American Samoa in 1988 to that in 1991?
Offer a very short reply. 1.13. What is the ratio of the Population growth (in %) in Slovenia in 1988 to that in 1991?
Your answer should be compact. 1.89. What is the ratio of the Population growth (in %) of Small states in 1989 to that in 1990?
Keep it short and to the point. 1.03. What is the ratio of the Population growth (in %) of American Samoa in 1989 to that in 1990?
Give a very brief answer. 1.05. What is the ratio of the Population growth (in %) in Slovenia in 1989 to that in 1990?
Offer a terse response. 0.92. What is the ratio of the Population growth (in %) of Small states in 1989 to that in 1991?
Give a very brief answer. 1.07. What is the ratio of the Population growth (in %) of American Samoa in 1989 to that in 1991?
Your answer should be compact. 1.06. What is the ratio of the Population growth (in %) of Slovenia in 1989 to that in 1991?
Provide a succinct answer. 1.19. What is the ratio of the Population growth (in %) of Small states in 1990 to that in 1991?
Ensure brevity in your answer.  1.04. What is the ratio of the Population growth (in %) of American Samoa in 1990 to that in 1991?
Give a very brief answer. 1.01. What is the ratio of the Population growth (in %) in Slovenia in 1990 to that in 1991?
Ensure brevity in your answer.  1.3. What is the difference between the highest and the second highest Population growth (in %) in Small states?
Your response must be concise. 0.05. What is the difference between the highest and the second highest Population growth (in %) of American Samoa?
Your response must be concise. 0.09. What is the difference between the highest and the second highest Population growth (in %) of Estonia?
Provide a short and direct response. 0.03. What is the difference between the highest and the second highest Population growth (in %) of Slovenia?
Ensure brevity in your answer.  0.04. What is the difference between the highest and the lowest Population growth (in %) in Small states?
Make the answer very short. 0.31. What is the difference between the highest and the lowest Population growth (in %) of American Samoa?
Make the answer very short. 1.05. What is the difference between the highest and the lowest Population growth (in %) in Estonia?
Provide a succinct answer. 1.07. What is the difference between the highest and the lowest Population growth (in %) in Slovenia?
Make the answer very short. 1.25. 